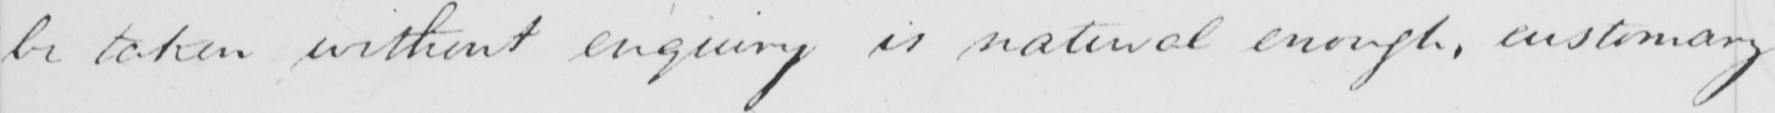Can you read and transcribe this handwriting? be taken without enquiry is natural enough , customary 